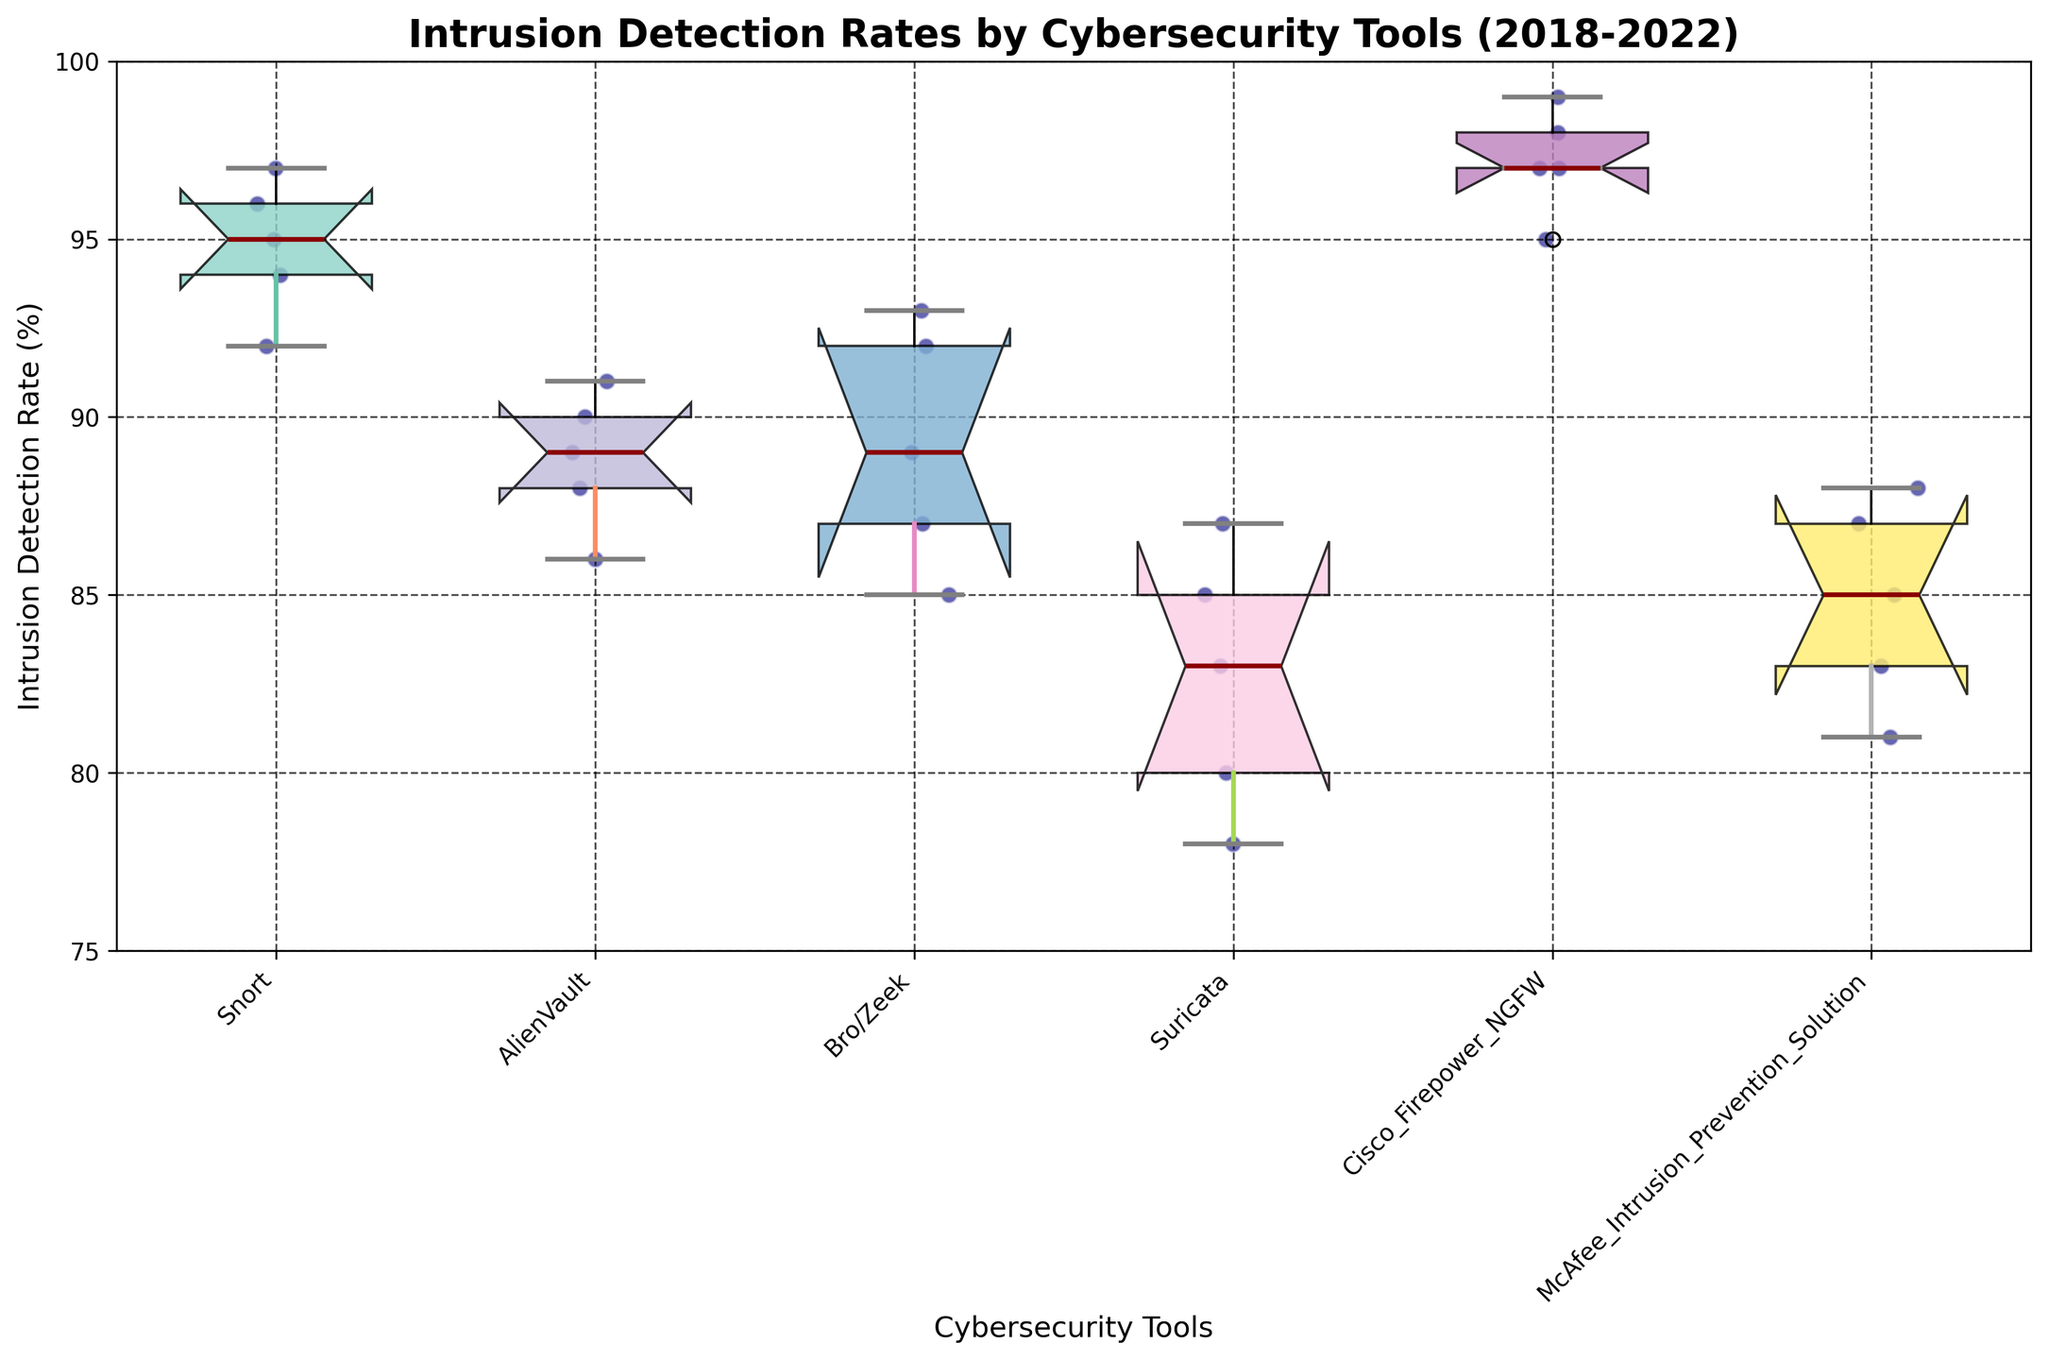What is the title of the plot? The title of the plot is located at the top and usually describes the subject of the figure. Here, it reads "Intrusion Detection Rates by Cybersecurity Tools (2018-2022)".
Answer: Intrusion Detection Rates by Cybersecurity Tools (2018-2022) Which cybersecurity tool has the highest median intrusion detection rate? The median is represented by the line inside each notched box. By looking at the figure, Cisco Firepower NGFW has the highest median line above all other tools.
Answer: Cisco Firepower NGFW What is the range of intrusion detection rates for Suricata? The range is the difference between the maximum and minimum values within a data set. In the case of Suricata, the whiskers (lines extending from the top and bottom of the box) cover values from around 78% to 87%.
Answer: 78% to 87% Which tool has the smallest interquartile range (IQR) of intrusion detection rates? The IQR is the range between the first quartile (bottom of the box) and the third quartile (top of the box). Cisco Firepower NGFW has the smallest IQR as represented by the narrowest box of all tools.
Answer: Cisco Firepower NGFW Are there any outliers among the intrusion detection rates for AlienVault? Outliers are typically represented by individual points outside the whiskers of the box plot. By inspecting AlienVault's box, there are no outliers shown in the figure.
Answer: No Which cybersecurity tool shows the most variability in intrusion detection rates? Variability can be inferred from the size of the box and the length of the whiskers. Suricata shows the most variability as it has the longest whiskers indicating a wide range of detection rates.
Answer: Suricata For which years does Snort have a consistently increasing trend in intrusion detection rate? By examining individual data points or scatter plots overlaid on Snort's box plot, we see that from 2018 to 2021, the detection rate consistently increased year by year. However, it decreased slightly in 2022.
Answer: 2018-2021 Compare the median intrusion detection rates of Snort and Bro/Zeek. Which one has a higher median? The median is the line inside each box. Comparing Snort and Bro/Zeek, Snort's median line is higher than that of Bro/Zeek, indicating a higher median intrusion detection rate.
Answer: Snort What can be inferred from the notches of the box plots when comparing Snort and McAfee Intrusion Prevention Solution? Notches give a rough indication of the confidence interval around the median. If the notches of two boxes don't overlap, their medians are significantly different. In this case, Snort and McAfee's notches don't overlap, suggesting a significant difference in their medians.
Answer: Snort's median significantly higher than McAfee's 